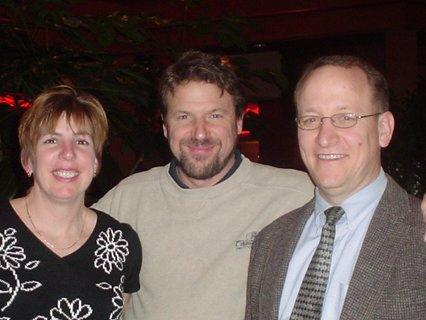The man in the middle has what feature? beard 